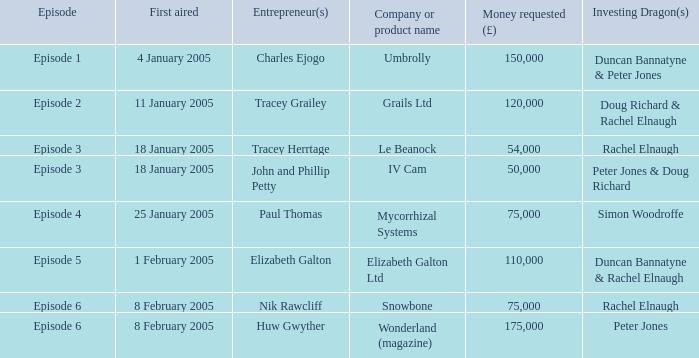What is the average money requested in the episode first aired on 18 January 2005 by the company/product name IV Cam 50000.0. Parse the table in full. {'header': ['Episode', 'First aired', 'Entrepreneur(s)', 'Company or product name', 'Money requested (£)', 'Investing Dragon(s)'], 'rows': [['Episode 1', '4 January 2005', 'Charles Ejogo', 'Umbrolly', '150,000', 'Duncan Bannatyne & Peter Jones'], ['Episode 2', '11 January 2005', 'Tracey Grailey', 'Grails Ltd', '120,000', 'Doug Richard & Rachel Elnaugh'], ['Episode 3', '18 January 2005', 'Tracey Herrtage', 'Le Beanock', '54,000', 'Rachel Elnaugh'], ['Episode 3', '18 January 2005', 'John and Phillip Petty', 'IV Cam', '50,000', 'Peter Jones & Doug Richard'], ['Episode 4', '25 January 2005', 'Paul Thomas', 'Mycorrhizal Systems', '75,000', 'Simon Woodroffe'], ['Episode 5', '1 February 2005', 'Elizabeth Galton', 'Elizabeth Galton Ltd', '110,000', 'Duncan Bannatyne & Rachel Elnaugh'], ['Episode 6', '8 February 2005', 'Nik Rawcliff', 'Snowbone', '75,000', 'Rachel Elnaugh'], ['Episode 6', '8 February 2005', 'Huw Gwyther', 'Wonderland (magazine)', '175,000', 'Peter Jones']]} 